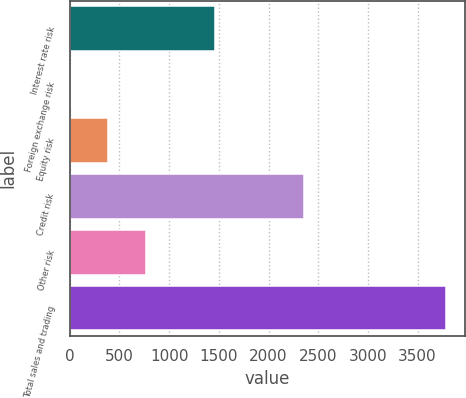Convert chart. <chart><loc_0><loc_0><loc_500><loc_500><bar_chart><fcel>Interest rate risk<fcel>Foreign exchange risk<fcel>Equity risk<fcel>Credit risk<fcel>Other risk<fcel>Total sales and trading<nl><fcel>1457<fcel>10<fcel>387.3<fcel>2360<fcel>764.6<fcel>3783<nl></chart> 